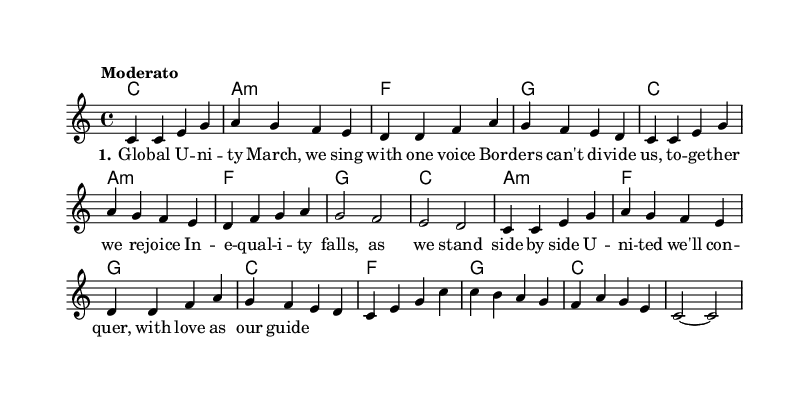What is the key signature of this music? The key signature is C major, which is indicated by the absence of any sharps or flats at the beginning of the staff.
Answer: C major What is the time signature of this piece? The time signature is located at the beginning of the piece, which is 4/4, indicating that there are four beats per measure and the quarter note gets one beat.
Answer: 4/4 What is the tempo marking for this piece? The tempo marking is found at the start of the sheet music, which states "Moderato," indicating a moderate speed of performance.
Answer: Moderato How many measures are there in the melody? By counting the individual groups of notes separated by vertical lines (bars), there are a total of 16 measures in the melody section.
Answer: 16 What is the first chord in the chord progression? The first chord is indicated by the first symbol at the beginning of the harmony section, which clearly shows it as a C major chord.
Answer: C Which voice carries the melody? The melody is specified in the sheet music under the label for the "lead" voice, which indicates that this voice is responsible for the melodic part.
Answer: lead How many stanzas of lyrics are present in the song? The lyrics provided indicate that there is one complete stanza, as shown by the stanza notation setting at the beginning of the lyric section.
Answer: 1 